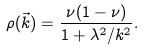<formula> <loc_0><loc_0><loc_500><loc_500>\rho ( \vec { k } ) = \frac { \nu ( 1 - \nu ) } { 1 + \lambda ^ { 2 } / k ^ { 2 } } .</formula> 